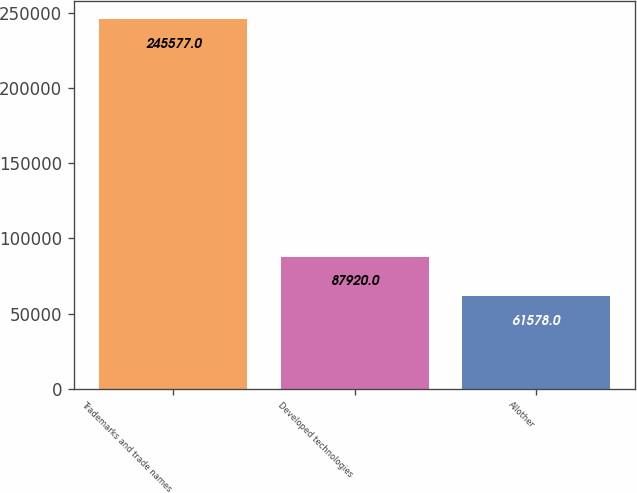Convert chart. <chart><loc_0><loc_0><loc_500><loc_500><bar_chart><fcel>Trademarks and trade names<fcel>Developed technologies<fcel>Allother<nl><fcel>245577<fcel>87920<fcel>61578<nl></chart> 